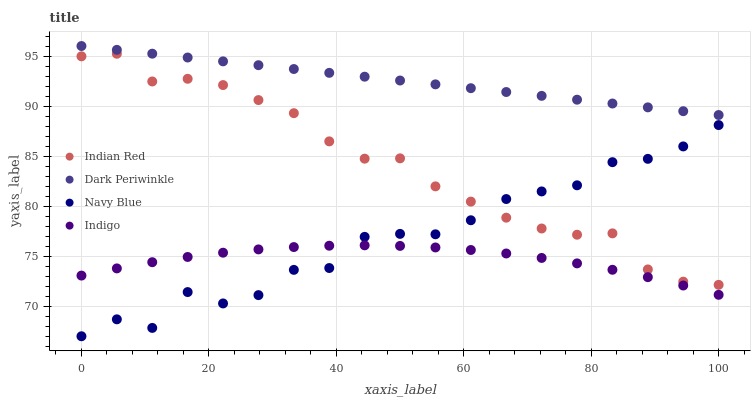Does Indigo have the minimum area under the curve?
Answer yes or no. Yes. Does Dark Periwinkle have the maximum area under the curve?
Answer yes or no. Yes. Does Dark Periwinkle have the minimum area under the curve?
Answer yes or no. No. Does Indigo have the maximum area under the curve?
Answer yes or no. No. Is Dark Periwinkle the smoothest?
Answer yes or no. Yes. Is Navy Blue the roughest?
Answer yes or no. Yes. Is Indigo the smoothest?
Answer yes or no. No. Is Indigo the roughest?
Answer yes or no. No. Does Navy Blue have the lowest value?
Answer yes or no. Yes. Does Indigo have the lowest value?
Answer yes or no. No. Does Dark Periwinkle have the highest value?
Answer yes or no. Yes. Does Indigo have the highest value?
Answer yes or no. No. Is Navy Blue less than Dark Periwinkle?
Answer yes or no. Yes. Is Dark Periwinkle greater than Indian Red?
Answer yes or no. Yes. Does Navy Blue intersect Indian Red?
Answer yes or no. Yes. Is Navy Blue less than Indian Red?
Answer yes or no. No. Is Navy Blue greater than Indian Red?
Answer yes or no. No. Does Navy Blue intersect Dark Periwinkle?
Answer yes or no. No. 